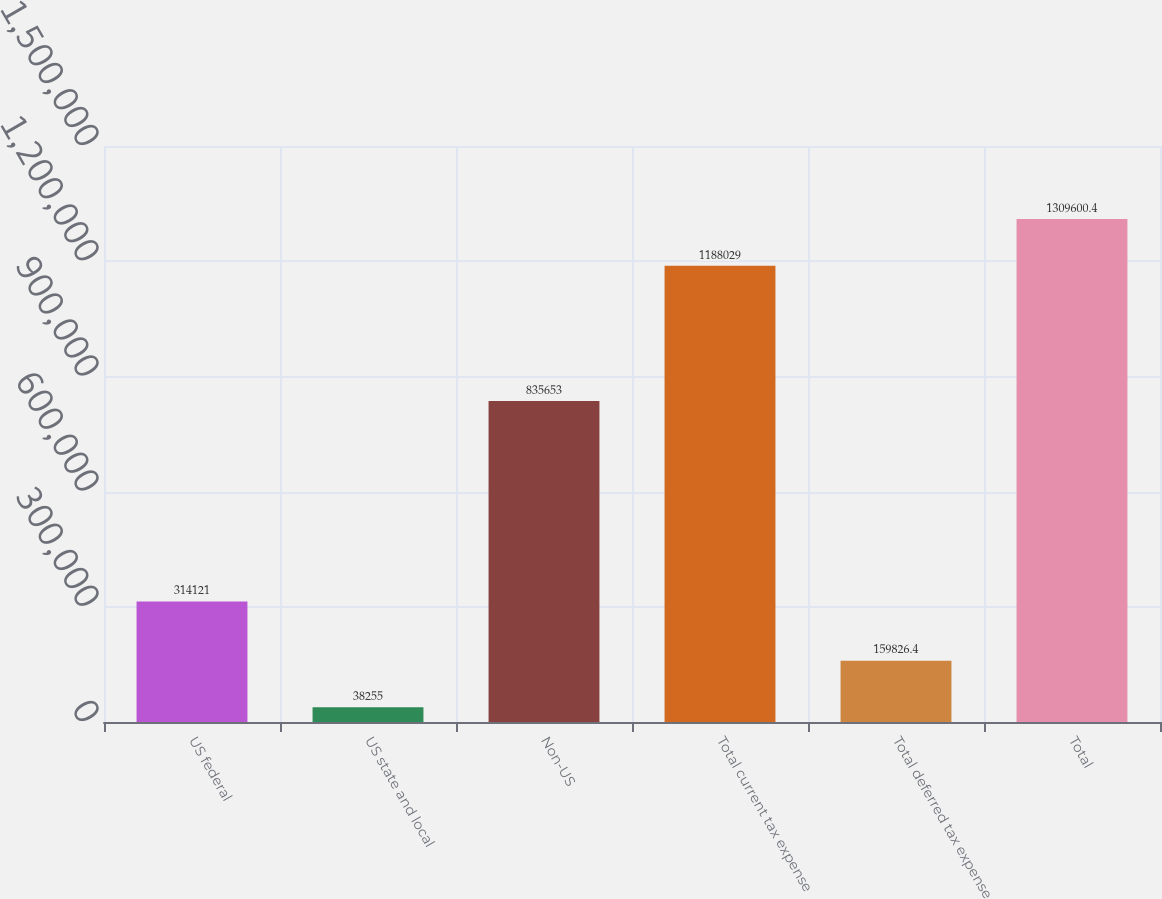Convert chart to OTSL. <chart><loc_0><loc_0><loc_500><loc_500><bar_chart><fcel>US federal<fcel>US state and local<fcel>Non-US<fcel>Total current tax expense<fcel>Total deferred tax expense<fcel>Total<nl><fcel>314121<fcel>38255<fcel>835653<fcel>1.18803e+06<fcel>159826<fcel>1.3096e+06<nl></chart> 